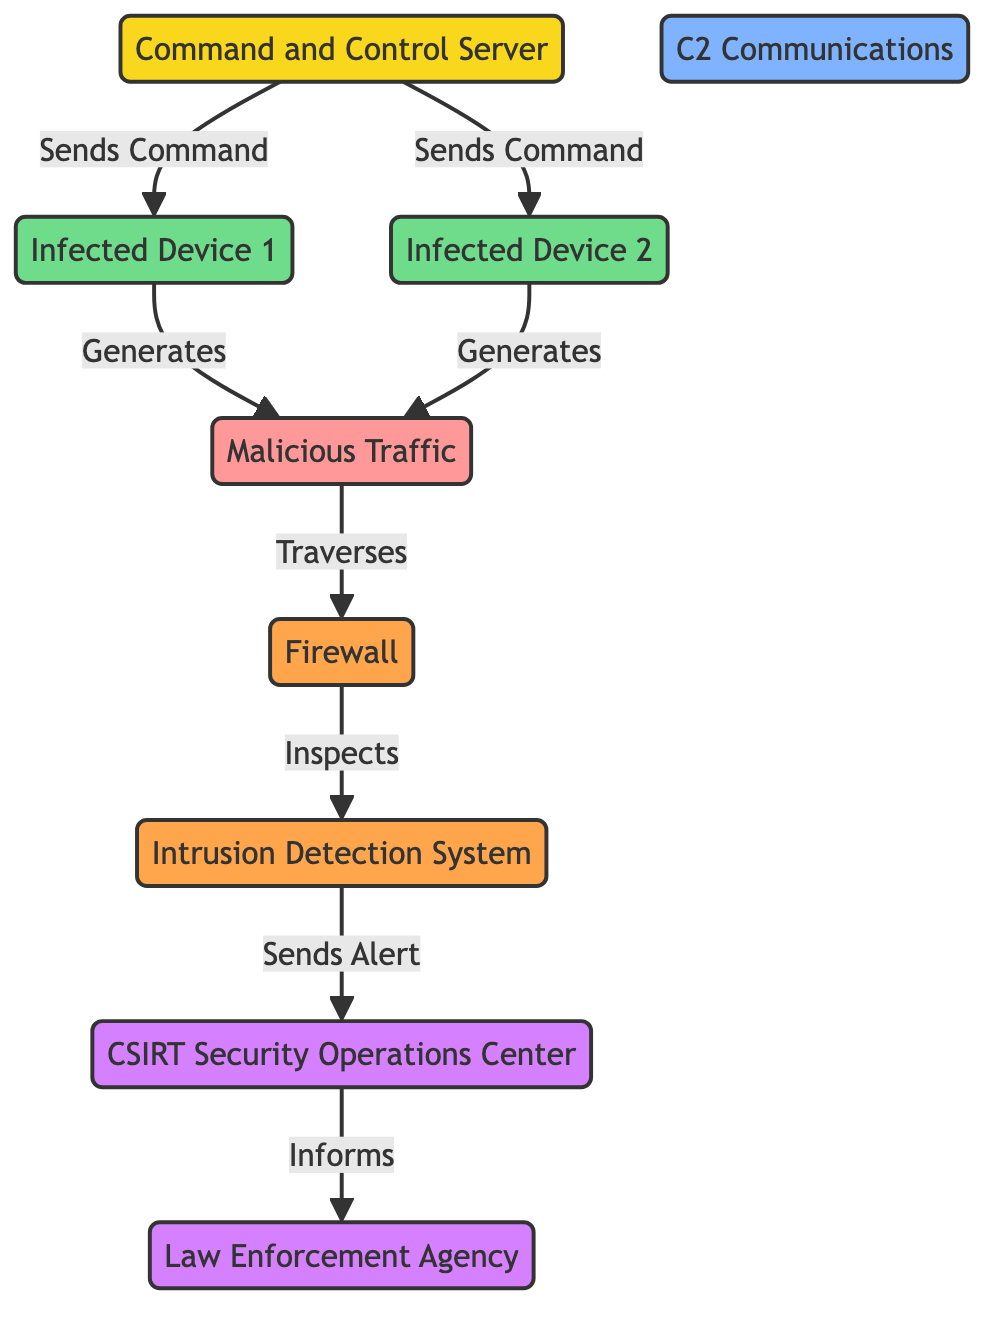What is the total number of nodes in the diagram? The diagram contains 9 distinct nodes: Command and Control Server, Infected Device 1, Infected Device 2, Malicious Traffic, C2 Communications, CSIRT Security Operations Center, Firewall, Intrusion Detection System, and Law Enforcement Agency.
Answer: 9 Which node generates malicious traffic? Both Infected Device 1 and Infected Device 2 generate malicious traffic, but since the question asks for one, we can refer to the first mentioned device, Infected Device 1.
Answer: Infected Device 1 What is the relationship between the C2 Server and the Infected Device 2? The relationship is labeled as "Sends Command," indicating that the C2 Server sends commands to Infected Device 2.
Answer: Sends Command How many times does the Intrusion Detection System send alerts? There is only one directed edge from the Intrusion Detection System to the CSIRT Security Operations Center labeled "Sends Alert," which indicates it only sends alerts once in the diagram context.
Answer: 1 What does the Firewall do in this infrastructure? The Firewall inspects incoming traffic from the malicious traffic, helping to identify and potentially block threats before they reach further systems.
Answer: Inspects Which entity is informed by the CSIRT Security Operations Center? The CSIRT Security Operations Center informs the Law Enforcement Agency about security incidents.
Answer: Law Enforcement Agency What is the path of malicious traffic through the components in the diagram? The path goes from Infected Device 1 or Infected Device 2 to Malicious Traffic, then to Firewall, then to IDS, and finally alerts the CSIRT Security Operations Center. This shows the flow that malicious traffic takes through the network of systems.
Answer: Infected Device 1 to Malicious Traffic to Firewall to IDS to CSIRT Security Operations Center What is the type of the node that receives alerts from the Intrusion Detection System? The node that receives alerts from the Intrusion Detection System is the CSIRT Security Operations Center, which serves as a central point for responding to security alerts.
Answer: CSIRT Security Operations Center 